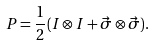<formula> <loc_0><loc_0><loc_500><loc_500>P = \frac { 1 } { 2 } ( I \otimes I + \vec { \sigma } \otimes \vec { \sigma } ) .</formula> 